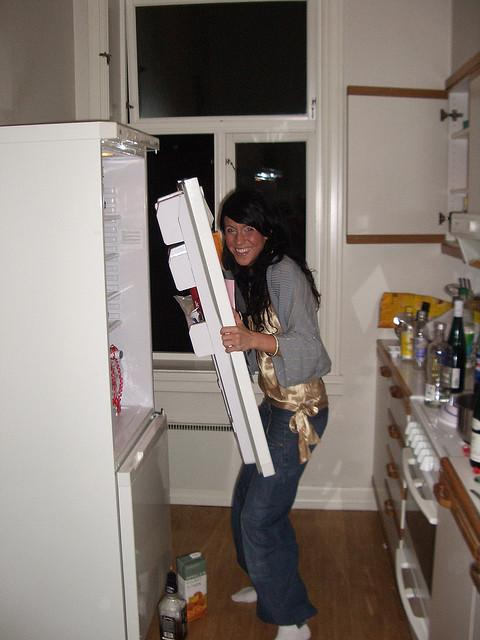What will happen to the refrigerator next? replaced 